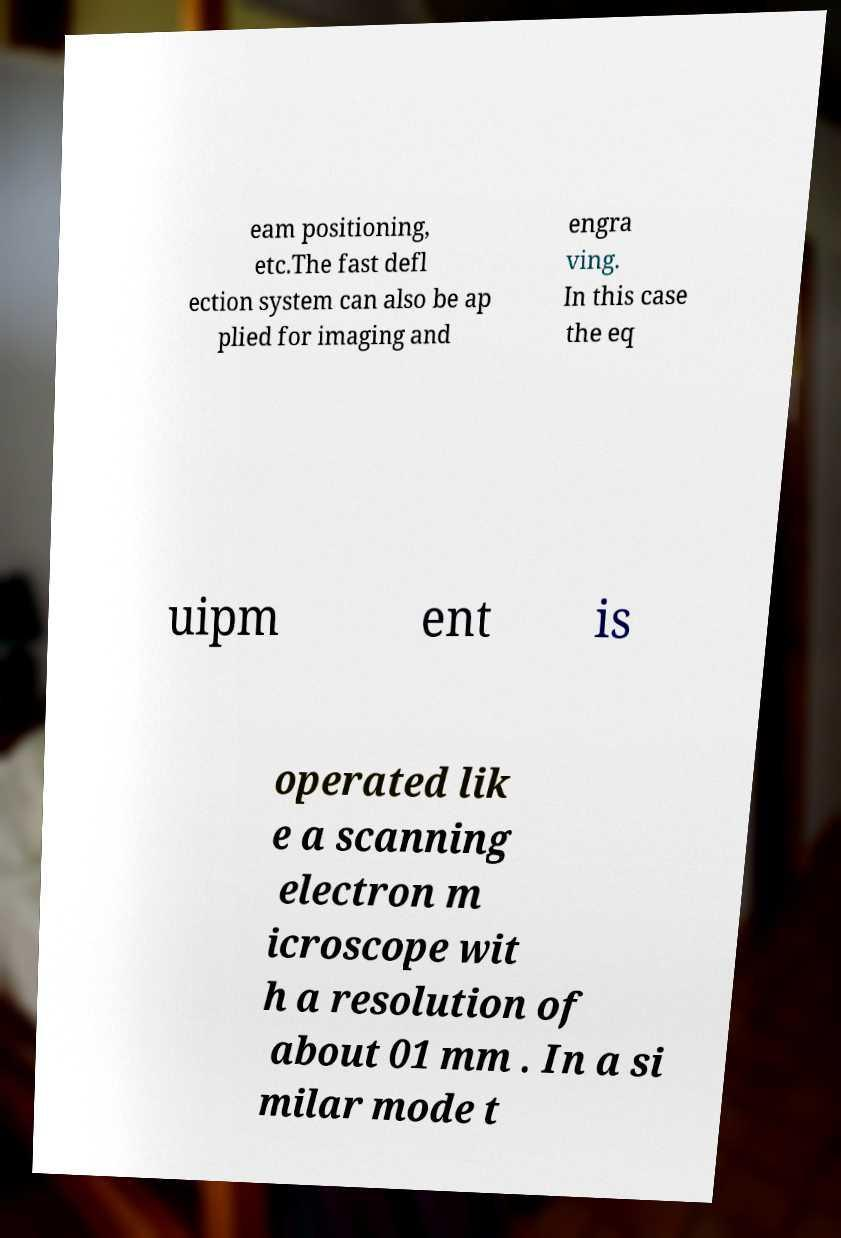Please read and relay the text visible in this image. What does it say? eam positioning, etc.The fast defl ection system can also be ap plied for imaging and engra ving. In this case the eq uipm ent is operated lik e a scanning electron m icroscope wit h a resolution of about 01 mm . In a si milar mode t 